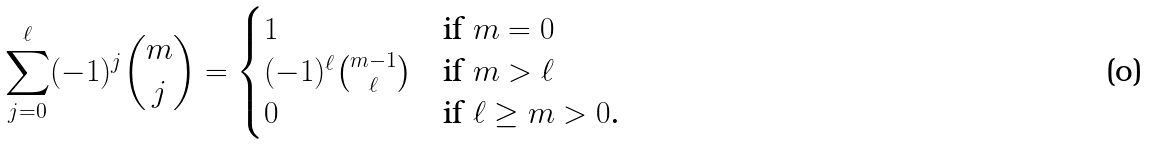Convert formula to latex. <formula><loc_0><loc_0><loc_500><loc_500>\sum _ { j = 0 } ^ { \ell } ( - 1 ) ^ { j } \binom { m } { j } = \begin{cases} 1 & \text {if $m=0$} \\ ( - 1 ) ^ { \ell } \binom { m - 1 } { \ell } & \text {if $m>\ell$} \\ 0 & \text {if $\ell\geq m>0$.} \end{cases}</formula> 